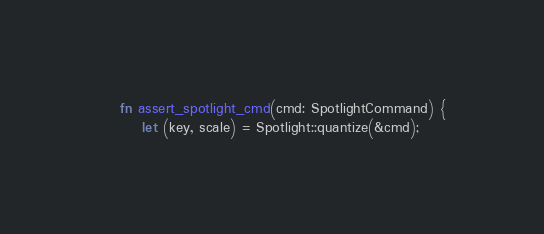Convert code to text. <code><loc_0><loc_0><loc_500><loc_500><_Rust_>
    fn assert_spotlight_cmd(cmd: SpotlightCommand) {
        let (key, scale) = Spotlight::quantize(&cmd);
</code> 